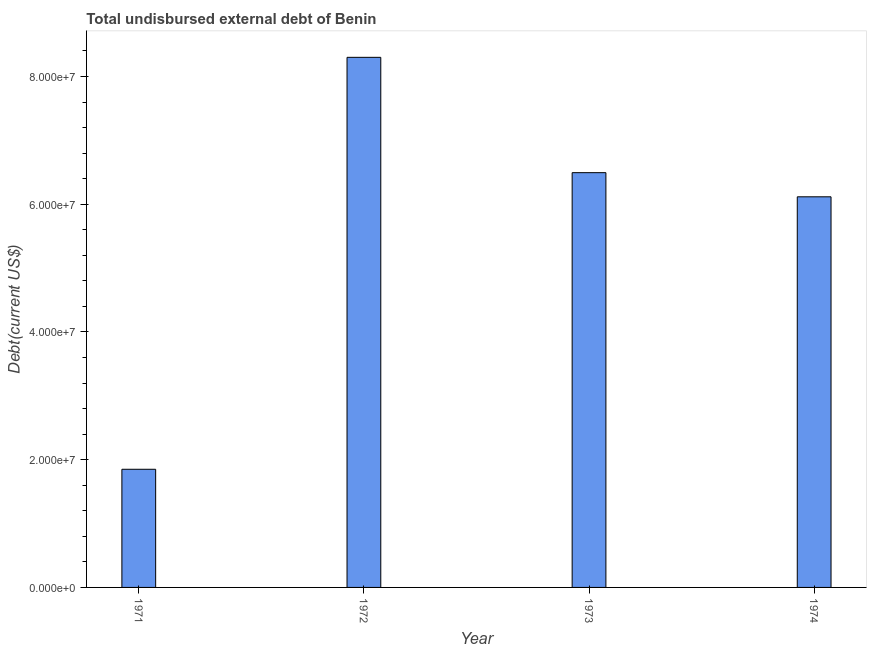Does the graph contain any zero values?
Make the answer very short. No. Does the graph contain grids?
Make the answer very short. No. What is the title of the graph?
Provide a succinct answer. Total undisbursed external debt of Benin. What is the label or title of the X-axis?
Your answer should be compact. Year. What is the label or title of the Y-axis?
Give a very brief answer. Debt(current US$). What is the total debt in 1973?
Provide a succinct answer. 6.49e+07. Across all years, what is the maximum total debt?
Ensure brevity in your answer.  8.30e+07. Across all years, what is the minimum total debt?
Offer a very short reply. 1.85e+07. In which year was the total debt maximum?
Keep it short and to the point. 1972. What is the sum of the total debt?
Your response must be concise. 2.28e+08. What is the difference between the total debt in 1972 and 1974?
Ensure brevity in your answer.  2.18e+07. What is the average total debt per year?
Keep it short and to the point. 5.69e+07. What is the median total debt?
Provide a succinct answer. 6.30e+07. In how many years, is the total debt greater than 4000000 US$?
Give a very brief answer. 4. What is the ratio of the total debt in 1971 to that in 1973?
Your answer should be very brief. 0.28. Is the total debt in 1972 less than that in 1974?
Keep it short and to the point. No. Is the difference between the total debt in 1971 and 1973 greater than the difference between any two years?
Your answer should be very brief. No. What is the difference between the highest and the second highest total debt?
Ensure brevity in your answer.  1.81e+07. Is the sum of the total debt in 1971 and 1973 greater than the maximum total debt across all years?
Ensure brevity in your answer.  Yes. What is the difference between the highest and the lowest total debt?
Ensure brevity in your answer.  6.45e+07. Are all the bars in the graph horizontal?
Offer a very short reply. No. How many years are there in the graph?
Keep it short and to the point. 4. Are the values on the major ticks of Y-axis written in scientific E-notation?
Your answer should be compact. Yes. What is the Debt(current US$) of 1971?
Your answer should be very brief. 1.85e+07. What is the Debt(current US$) in 1972?
Your answer should be compact. 8.30e+07. What is the Debt(current US$) of 1973?
Offer a terse response. 6.49e+07. What is the Debt(current US$) in 1974?
Your answer should be very brief. 6.12e+07. What is the difference between the Debt(current US$) in 1971 and 1972?
Make the answer very short. -6.45e+07. What is the difference between the Debt(current US$) in 1971 and 1973?
Ensure brevity in your answer.  -4.64e+07. What is the difference between the Debt(current US$) in 1971 and 1974?
Your answer should be very brief. -4.27e+07. What is the difference between the Debt(current US$) in 1972 and 1973?
Ensure brevity in your answer.  1.81e+07. What is the difference between the Debt(current US$) in 1972 and 1974?
Provide a short and direct response. 2.18e+07. What is the difference between the Debt(current US$) in 1973 and 1974?
Provide a short and direct response. 3.78e+06. What is the ratio of the Debt(current US$) in 1971 to that in 1972?
Ensure brevity in your answer.  0.22. What is the ratio of the Debt(current US$) in 1971 to that in 1973?
Ensure brevity in your answer.  0.28. What is the ratio of the Debt(current US$) in 1971 to that in 1974?
Ensure brevity in your answer.  0.3. What is the ratio of the Debt(current US$) in 1972 to that in 1973?
Make the answer very short. 1.28. What is the ratio of the Debt(current US$) in 1972 to that in 1974?
Make the answer very short. 1.36. What is the ratio of the Debt(current US$) in 1973 to that in 1974?
Offer a terse response. 1.06. 